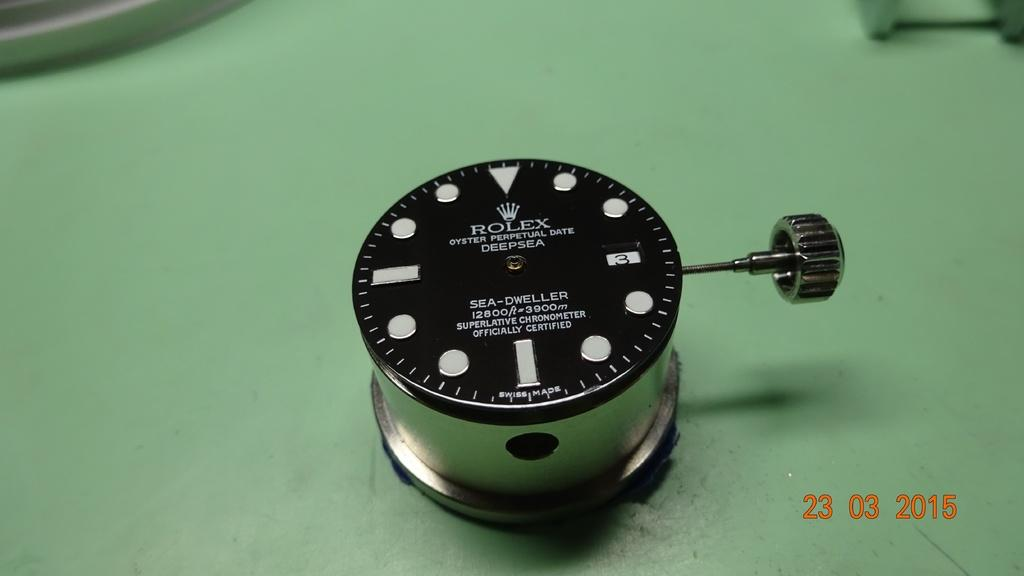<image>
Give a short and clear explanation of the subsequent image. A Rolex product is shown with an official certification that it is a superlative chronometer 